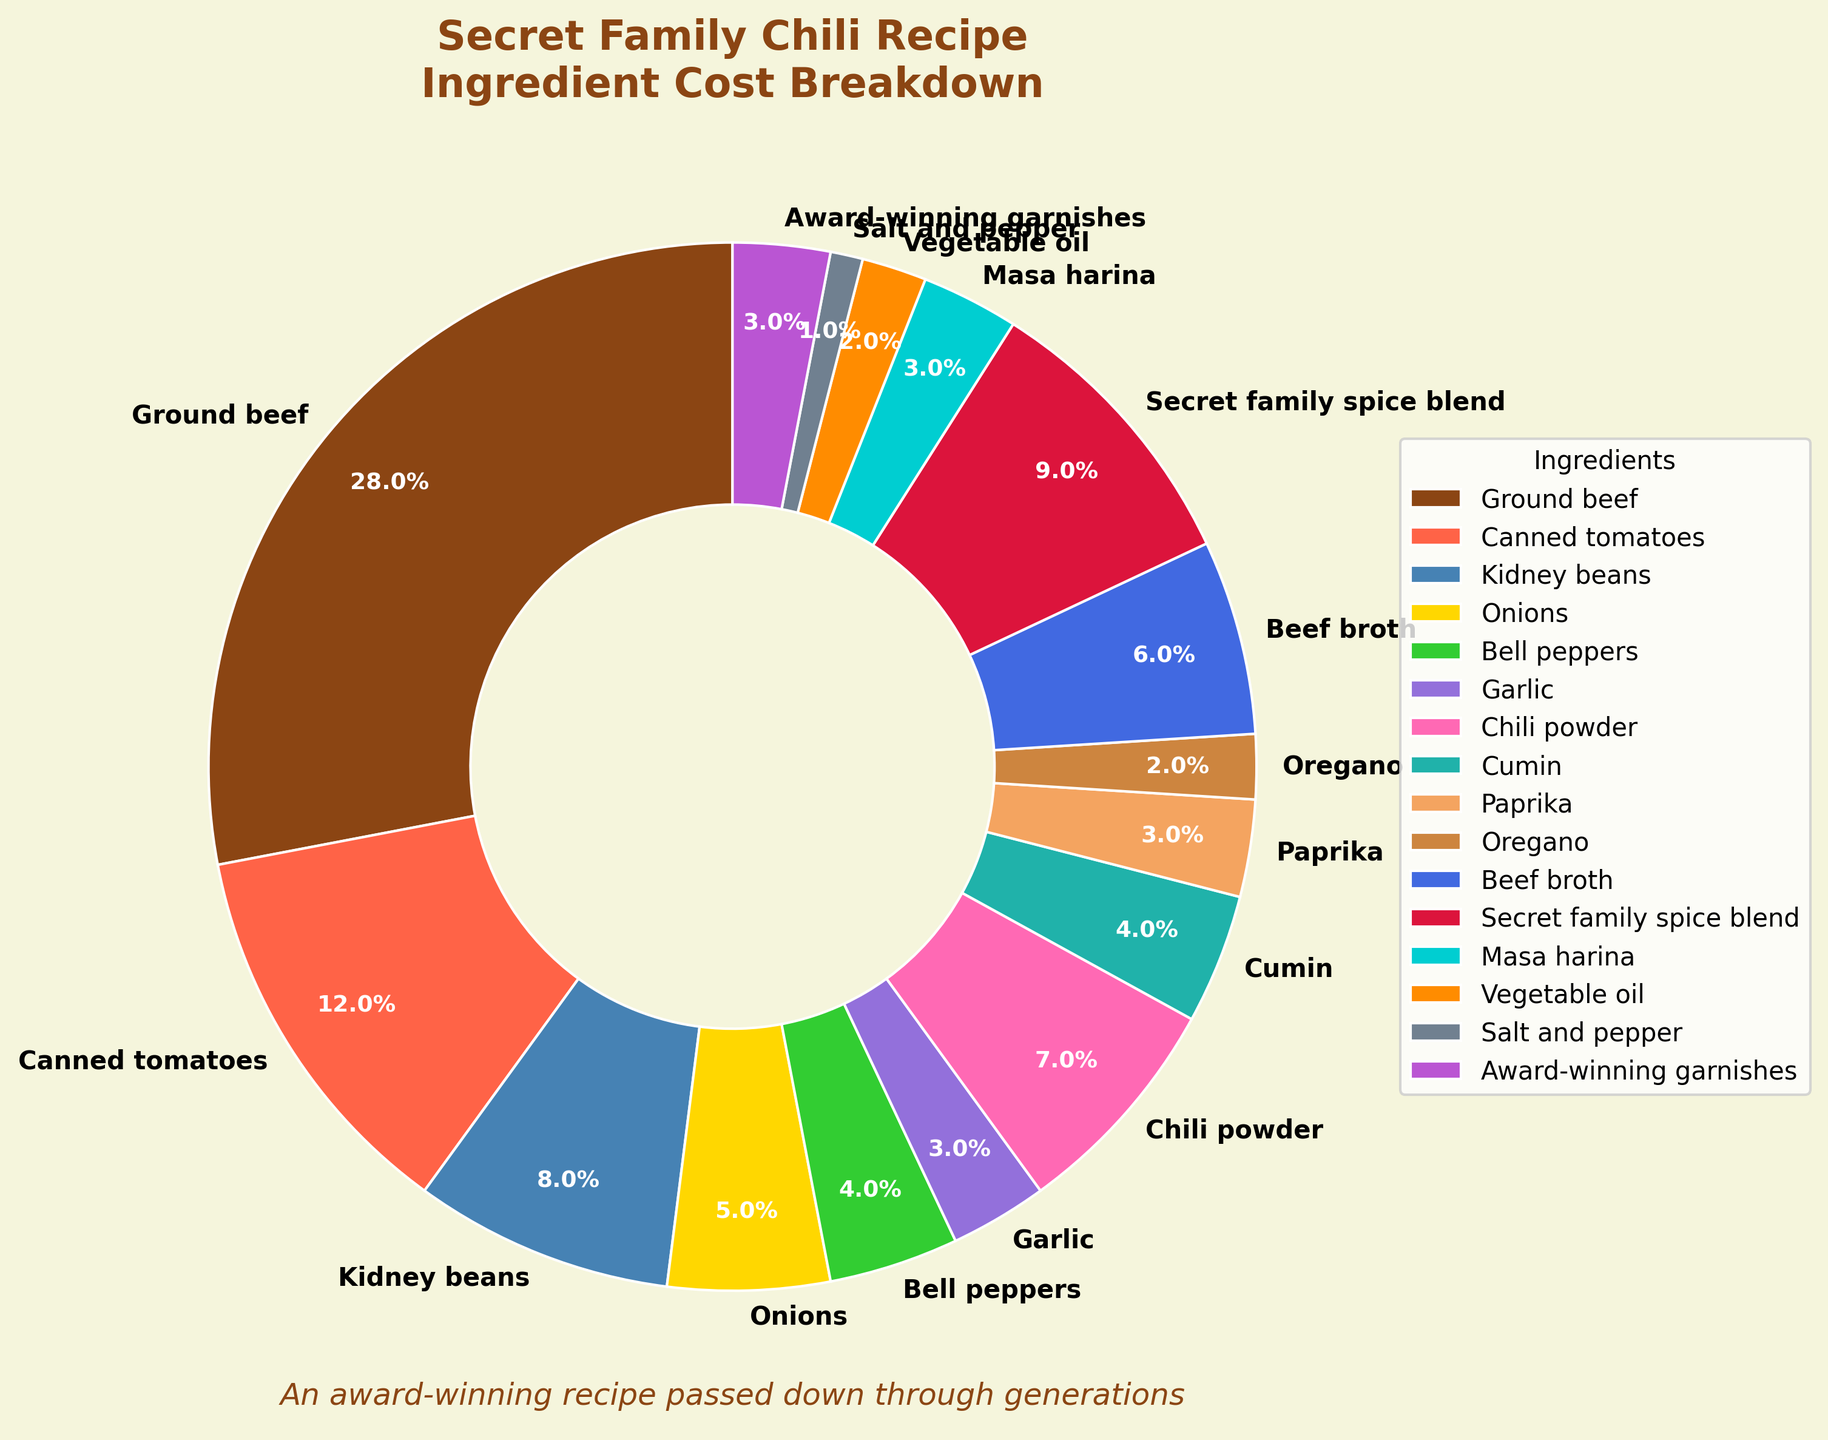Which ingredient has the highest cost percentage? According to the pie chart, the ingredient with the highest percentage of the total cost is ground beef.
Answer: Ground beef Which two ingredients combined have the lowest cost percentage? From the pie chart, salt and pepper (1%) and oregano (2%) together have the lowest combined cost percentage of 3%.
Answer: Salt and pepper, and oregano What is the cost percentage difference between ground beef and the secret family spice blend? The pie chart shows ground beef at 28% and the secret family spice blend at 9%. The difference is 28% - 9% = 19%.
Answer: 19% Are the sums of the percentages of cumin and paprika higher or lower than the percentage of ground beef? From the pie chart, cumin is 4% and paprika is 3%, totaling 7%. Ground beef is 28%, so 7% is lower than 28%.
Answer: Lower What's the sum of the ingredient costs for all types of peppers (bell peppers, chili powder, and paprika)? According to the pie chart, bell peppers are 4%, chili powder is 7%, and paprika is 3%. The sum is 4% + 7% + 3% = 14%.
Answer: 14% Which ingredient is represented by a green color, and what is its cost percentage? Visually, the green section of the pie chart corresponds to bell peppers. The chart indicates bell peppers have a cost percentage of 4%.
Answer: Bell peppers, 4% By how much does the cost percentage of canned tomatoes exceed that of kidney beans? The pie chart shows canned tomatoes at 12% and kidney beans at 8%. The excess is 12% - 8% = 4%.
Answer: 4% Which ingredients have a cost percentage of 3%, and can you list them? From the pie chart, the sections labeled 3% correspond to garlic, paprika, masa harina, and award-winning garnishes.
Answer: Garlic, paprika, masa harina, award-winning garnishes Is the total cost percentage of cumin and vegetable oil greater or less than the cost percentage of beef broth? The pie chart shows cumin at 4% and vegetable oil at 2%, totaling 6%. Beef broth is also 6%, making them equal.
Answer: Equal Which group has a higher total cost percentage: onions and bell peppers or garlic and award-winning garnishes? From the pie chart, onions are 5% and bell peppers are 4%, totaling 9%. Garlic is 3% and award-winning garnishes are 3%, totaling 6%. Therefore, onions and bell peppers have a higher total cost percentage.
Answer: Onions and bell peppers 